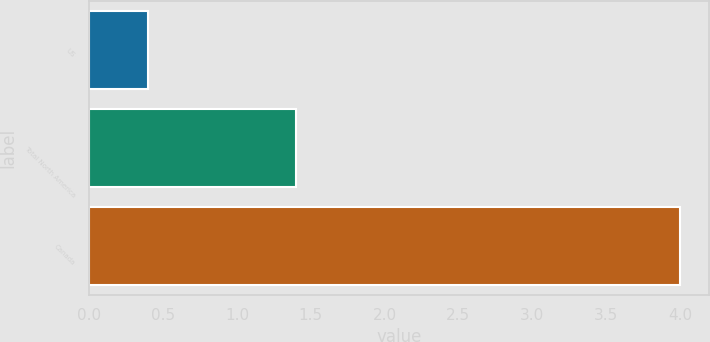<chart> <loc_0><loc_0><loc_500><loc_500><bar_chart><fcel>US<fcel>Total North America<fcel>Canada<nl><fcel>0.4<fcel>1.4<fcel>4<nl></chart> 